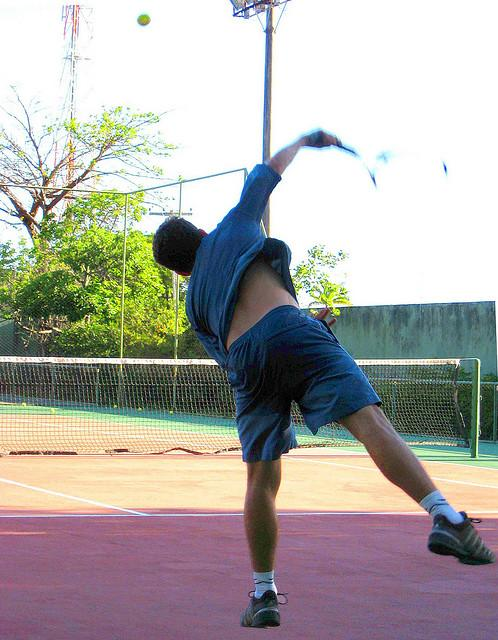What move has the player just used? serve 